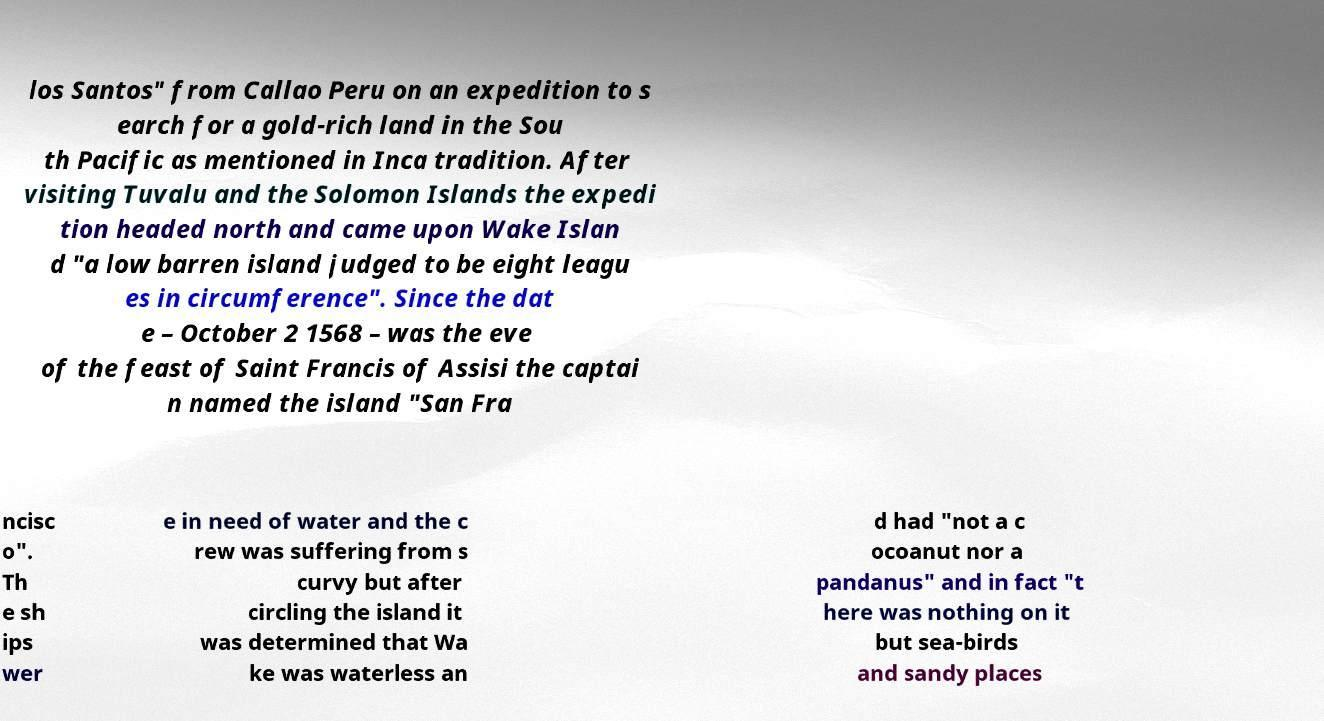There's text embedded in this image that I need extracted. Can you transcribe it verbatim? los Santos" from Callao Peru on an expedition to s earch for a gold-rich land in the Sou th Pacific as mentioned in Inca tradition. After visiting Tuvalu and the Solomon Islands the expedi tion headed north and came upon Wake Islan d "a low barren island judged to be eight leagu es in circumference". Since the dat e – October 2 1568 – was the eve of the feast of Saint Francis of Assisi the captai n named the island "San Fra ncisc o". Th e sh ips wer e in need of water and the c rew was suffering from s curvy but after circling the island it was determined that Wa ke was waterless an d had "not a c ocoanut nor a pandanus" and in fact "t here was nothing on it but sea-birds and sandy places 